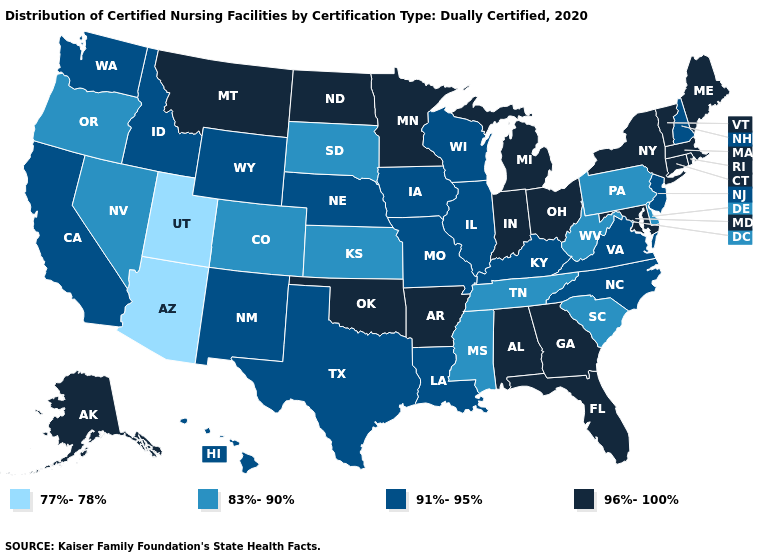Which states hav the highest value in the West?
Answer briefly. Alaska, Montana. Does Illinois have the highest value in the MidWest?
Keep it brief. No. What is the highest value in the West ?
Concise answer only. 96%-100%. What is the highest value in the MidWest ?
Quick response, please. 96%-100%. Does Maine have the highest value in the USA?
Quick response, please. Yes. What is the highest value in states that border North Carolina?
Short answer required. 96%-100%. Among the states that border Idaho , does Utah have the lowest value?
Short answer required. Yes. Name the states that have a value in the range 77%-78%?
Concise answer only. Arizona, Utah. Which states hav the highest value in the Northeast?
Concise answer only. Connecticut, Maine, Massachusetts, New York, Rhode Island, Vermont. What is the value of Arkansas?
Give a very brief answer. 96%-100%. Among the states that border Oregon , which have the lowest value?
Quick response, please. Nevada. Name the states that have a value in the range 91%-95%?
Be succinct. California, Hawaii, Idaho, Illinois, Iowa, Kentucky, Louisiana, Missouri, Nebraska, New Hampshire, New Jersey, New Mexico, North Carolina, Texas, Virginia, Washington, Wisconsin, Wyoming. Does Nebraska have the highest value in the USA?
Short answer required. No. Does Mississippi have the lowest value in the South?
Be succinct. Yes. What is the highest value in the USA?
Keep it brief. 96%-100%. 